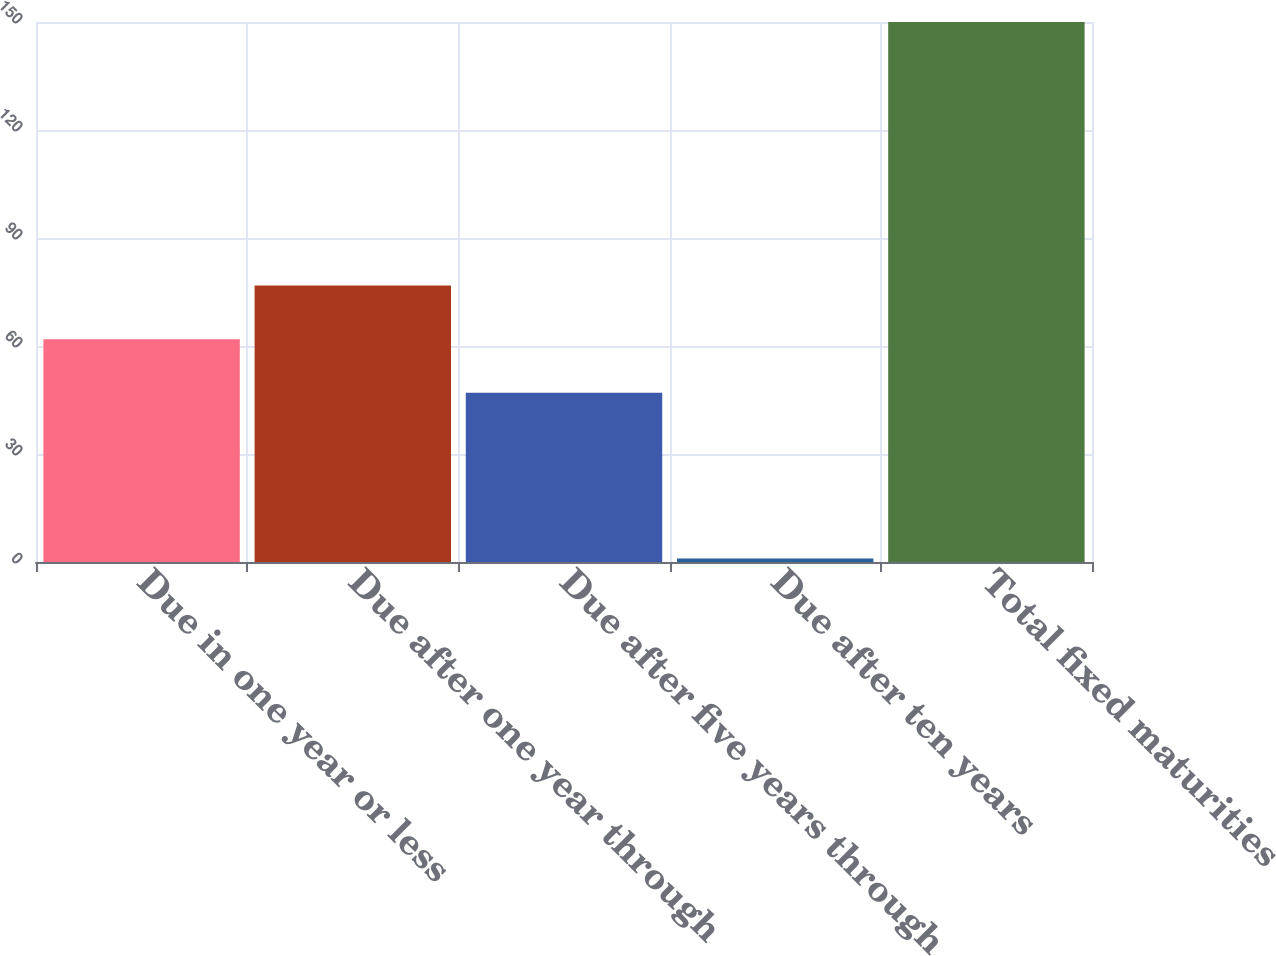<chart> <loc_0><loc_0><loc_500><loc_500><bar_chart><fcel>Due in one year or less<fcel>Due after one year through<fcel>Due after five years through<fcel>Due after ten years<fcel>Total fixed maturities<nl><fcel>61.9<fcel>76.8<fcel>47<fcel>1<fcel>150<nl></chart> 